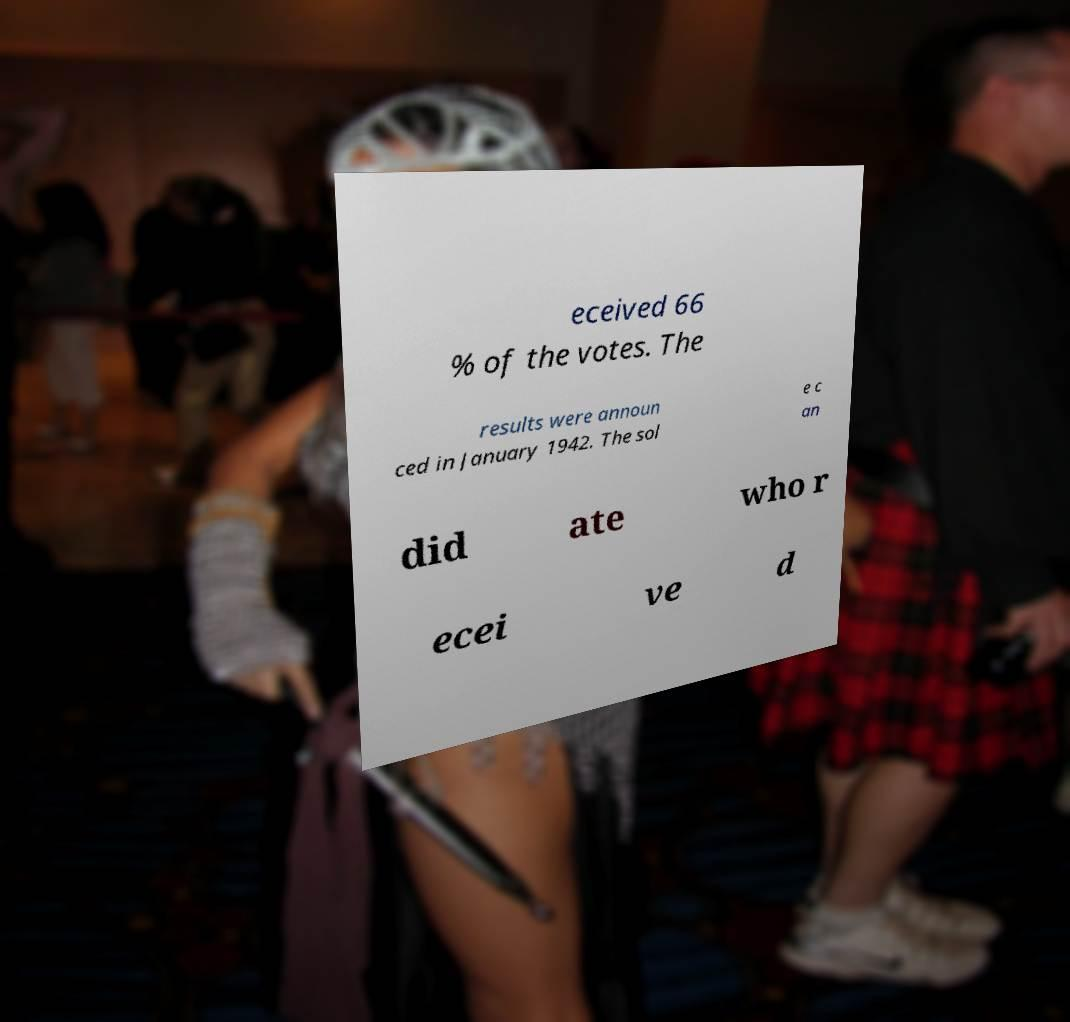Please identify and transcribe the text found in this image. eceived 66 % of the votes. The results were announ ced in January 1942. The sol e c an did ate who r ecei ve d 